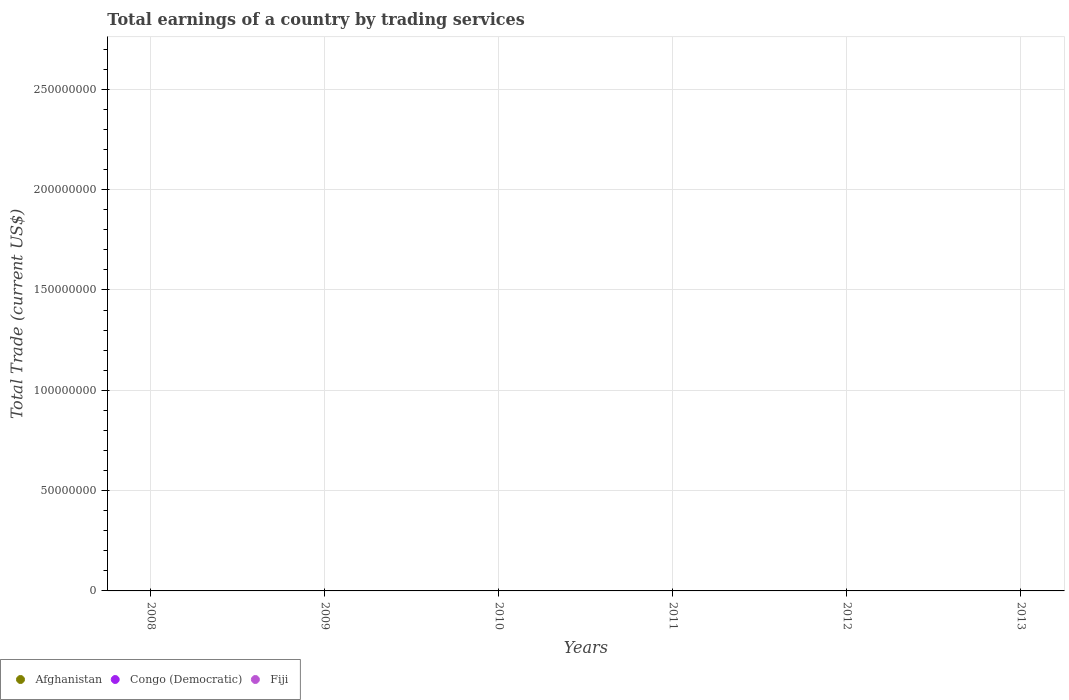What is the total total earnings in Afghanistan in the graph?
Your answer should be compact. 0. What is the difference between the total earnings in Congo (Democratic) in 2011 and the total earnings in Afghanistan in 2009?
Offer a terse response. 0. In how many years, is the total earnings in Congo (Democratic) greater than 20000000 US$?
Provide a succinct answer. 0. In how many years, is the total earnings in Afghanistan greater than the average total earnings in Afghanistan taken over all years?
Your response must be concise. 0. Is it the case that in every year, the sum of the total earnings in Fiji and total earnings in Afghanistan  is greater than the total earnings in Congo (Democratic)?
Ensure brevity in your answer.  No. Is the total earnings in Congo (Democratic) strictly greater than the total earnings in Afghanistan over the years?
Offer a very short reply. Yes. How many dotlines are there?
Provide a short and direct response. 0. What is the difference between two consecutive major ticks on the Y-axis?
Make the answer very short. 5.00e+07. How are the legend labels stacked?
Give a very brief answer. Horizontal. What is the title of the graph?
Offer a very short reply. Total earnings of a country by trading services. Does "Ecuador" appear as one of the legend labels in the graph?
Provide a succinct answer. No. What is the label or title of the Y-axis?
Ensure brevity in your answer.  Total Trade (current US$). What is the Total Trade (current US$) in Fiji in 2008?
Your answer should be very brief. 0. What is the Total Trade (current US$) in Fiji in 2009?
Offer a very short reply. 0. What is the Total Trade (current US$) in Afghanistan in 2010?
Your response must be concise. 0. What is the Total Trade (current US$) in Congo (Democratic) in 2010?
Give a very brief answer. 0. What is the Total Trade (current US$) of Fiji in 2010?
Offer a very short reply. 0. What is the Total Trade (current US$) of Afghanistan in 2011?
Your response must be concise. 0. What is the Total Trade (current US$) in Congo (Democratic) in 2011?
Give a very brief answer. 0. What is the Total Trade (current US$) in Congo (Democratic) in 2012?
Offer a very short reply. 0. What is the Total Trade (current US$) of Fiji in 2012?
Your answer should be very brief. 0. What is the Total Trade (current US$) in Congo (Democratic) in 2013?
Your answer should be very brief. 0. What is the Total Trade (current US$) of Fiji in 2013?
Give a very brief answer. 0. What is the total Total Trade (current US$) of Congo (Democratic) in the graph?
Ensure brevity in your answer.  0. What is the average Total Trade (current US$) in Afghanistan per year?
Offer a very short reply. 0. What is the average Total Trade (current US$) in Congo (Democratic) per year?
Keep it short and to the point. 0. 